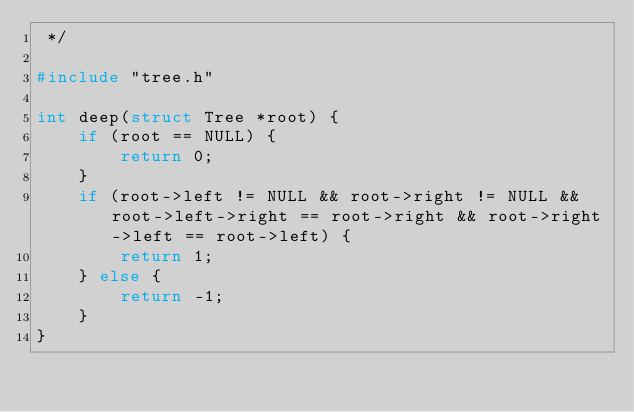Convert code to text. <code><loc_0><loc_0><loc_500><loc_500><_C_> */

#include "tree.h"

int deep(struct Tree *root) {
    if (root == NULL) {
        return 0;
    }
    if (root->left != NULL && root->right != NULL && root->left->right == root->right && root->right->left == root->left) {
        return 1;
    } else {
        return -1;
    }
}
</code> 